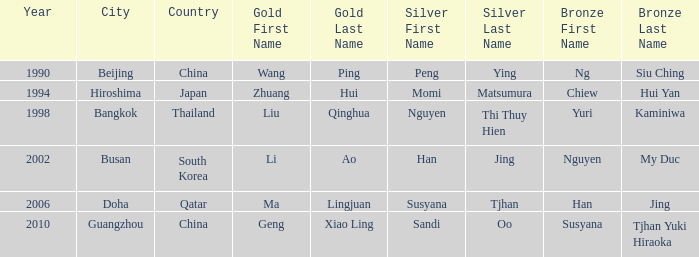What's the lowest Year with the Location of Bangkok? 1998.0. Give me the full table as a dictionary. {'header': ['Year', 'City', 'Country', 'Gold First Name', 'Gold Last Name', 'Silver First Name', 'Silver Last Name', 'Bronze First Name', 'Bronze Last Name'], 'rows': [['1990', 'Beijing', 'China', 'Wang', 'Ping', 'Peng', 'Ying', 'Ng', 'Siu Ching'], ['1994', 'Hiroshima', 'Japan', 'Zhuang', 'Hui', 'Momi', 'Matsumura', 'Chiew', 'Hui Yan'], ['1998', 'Bangkok', 'Thailand', 'Liu', 'Qinghua', 'Nguyen', 'Thi Thuy Hien', 'Yuri', 'Kaminiwa'], ['2002', 'Busan', 'South Korea', 'Li', 'Ao', 'Han', 'Jing', 'Nguyen', 'My Duc'], ['2006', 'Doha', 'Qatar', 'Ma', 'Lingjuan', 'Susyana', 'Tjhan', 'Han', 'Jing'], ['2010', 'Guangzhou', 'China', 'Geng', 'Xiao Ling', 'Sandi', 'Oo', 'Susyana', 'Tjhan Yuki Hiraoka']]} 